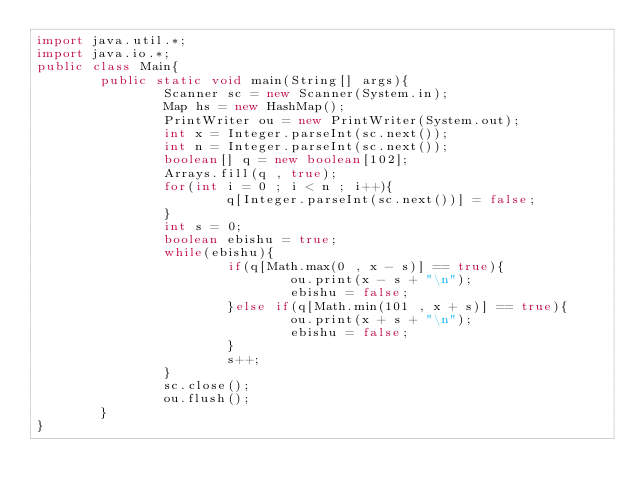Convert code to text. <code><loc_0><loc_0><loc_500><loc_500><_Java_>import java.util.*;
import java.io.*;
public class Main{
        public static void main(String[] args){
                Scanner sc = new Scanner(System.in);
                Map hs = new HashMap();
                PrintWriter ou = new PrintWriter(System.out);
                int x = Integer.parseInt(sc.next());
                int n = Integer.parseInt(sc.next());
                boolean[] q = new boolean[102];
                Arrays.fill(q , true);
                for(int i = 0 ; i < n ; i++){
                        q[Integer.parseInt(sc.next())] = false;
                }
                int s = 0;
                boolean ebishu = true;
                while(ebishu){
                        if(q[Math.max(0 , x - s)] == true){
                                ou.print(x - s + "\n");
                                ebishu = false;
                        }else if(q[Math.min(101 , x + s)] == true){
                                ou.print(x + s + "\n");
                                ebishu = false;
                        }
                        s++;
                }
                sc.close();
                ou.flush();
        }
}</code> 